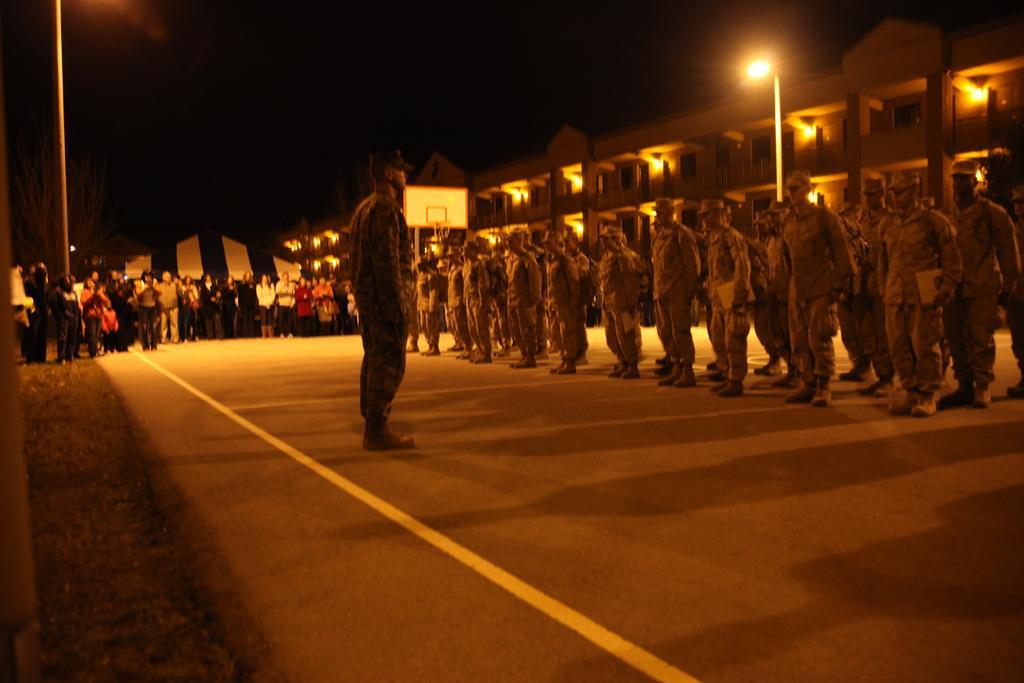In one or two sentences, can you explain what this image depicts? This image is taken during the night time. In this image we can see the buildings, lights, poles, board and also the tent for shelter. We can also see the people standing on the road. 